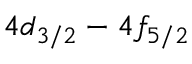<formula> <loc_0><loc_0><loc_500><loc_500>4 d _ { 3 / 2 } - 4 f _ { 5 / 2 }</formula> 